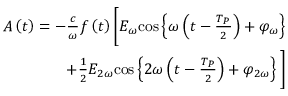<formula> <loc_0><loc_0><loc_500><loc_500>\begin{array} { r } { A \left ( t \right ) = - \frac { c } { \omega } f \left ( t \right ) \left [ E _ { \omega } { \cos } \left \{ \omega \left ( t - \frac { T _ { P } } { 2 } \right ) + \varphi _ { \omega } \right \} } \\ { + \frac { 1 } { 2 } E _ { 2 \omega } { \cos } \left \{ 2 \omega \left ( t - \frac { T _ { P } } { 2 } \right ) + \varphi _ { 2 \omega } \right \} \right ] } \end{array}</formula> 